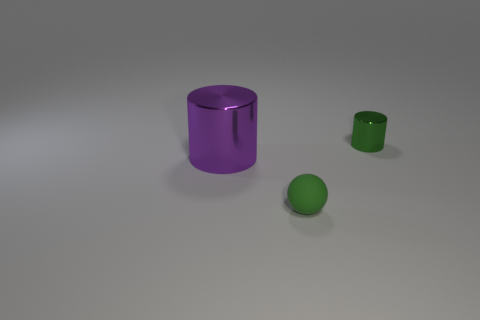How many other things are there of the same size as the purple thing? Upon closer examination, it appears there are no other objects that match the size of the purple cylinder exactly. Both the green sphere and the smaller green cylinder are significantly different in size when compared to the purple one. 